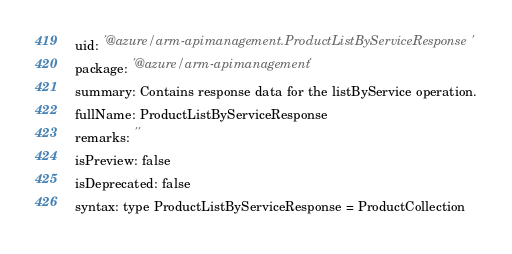Convert code to text. <code><loc_0><loc_0><loc_500><loc_500><_YAML_>uid: '@azure/arm-apimanagement.ProductListByServiceResponse'
package: '@azure/arm-apimanagement'
summary: Contains response data for the listByService operation.
fullName: ProductListByServiceResponse
remarks: ''
isPreview: false
isDeprecated: false
syntax: type ProductListByServiceResponse = ProductCollection
</code> 